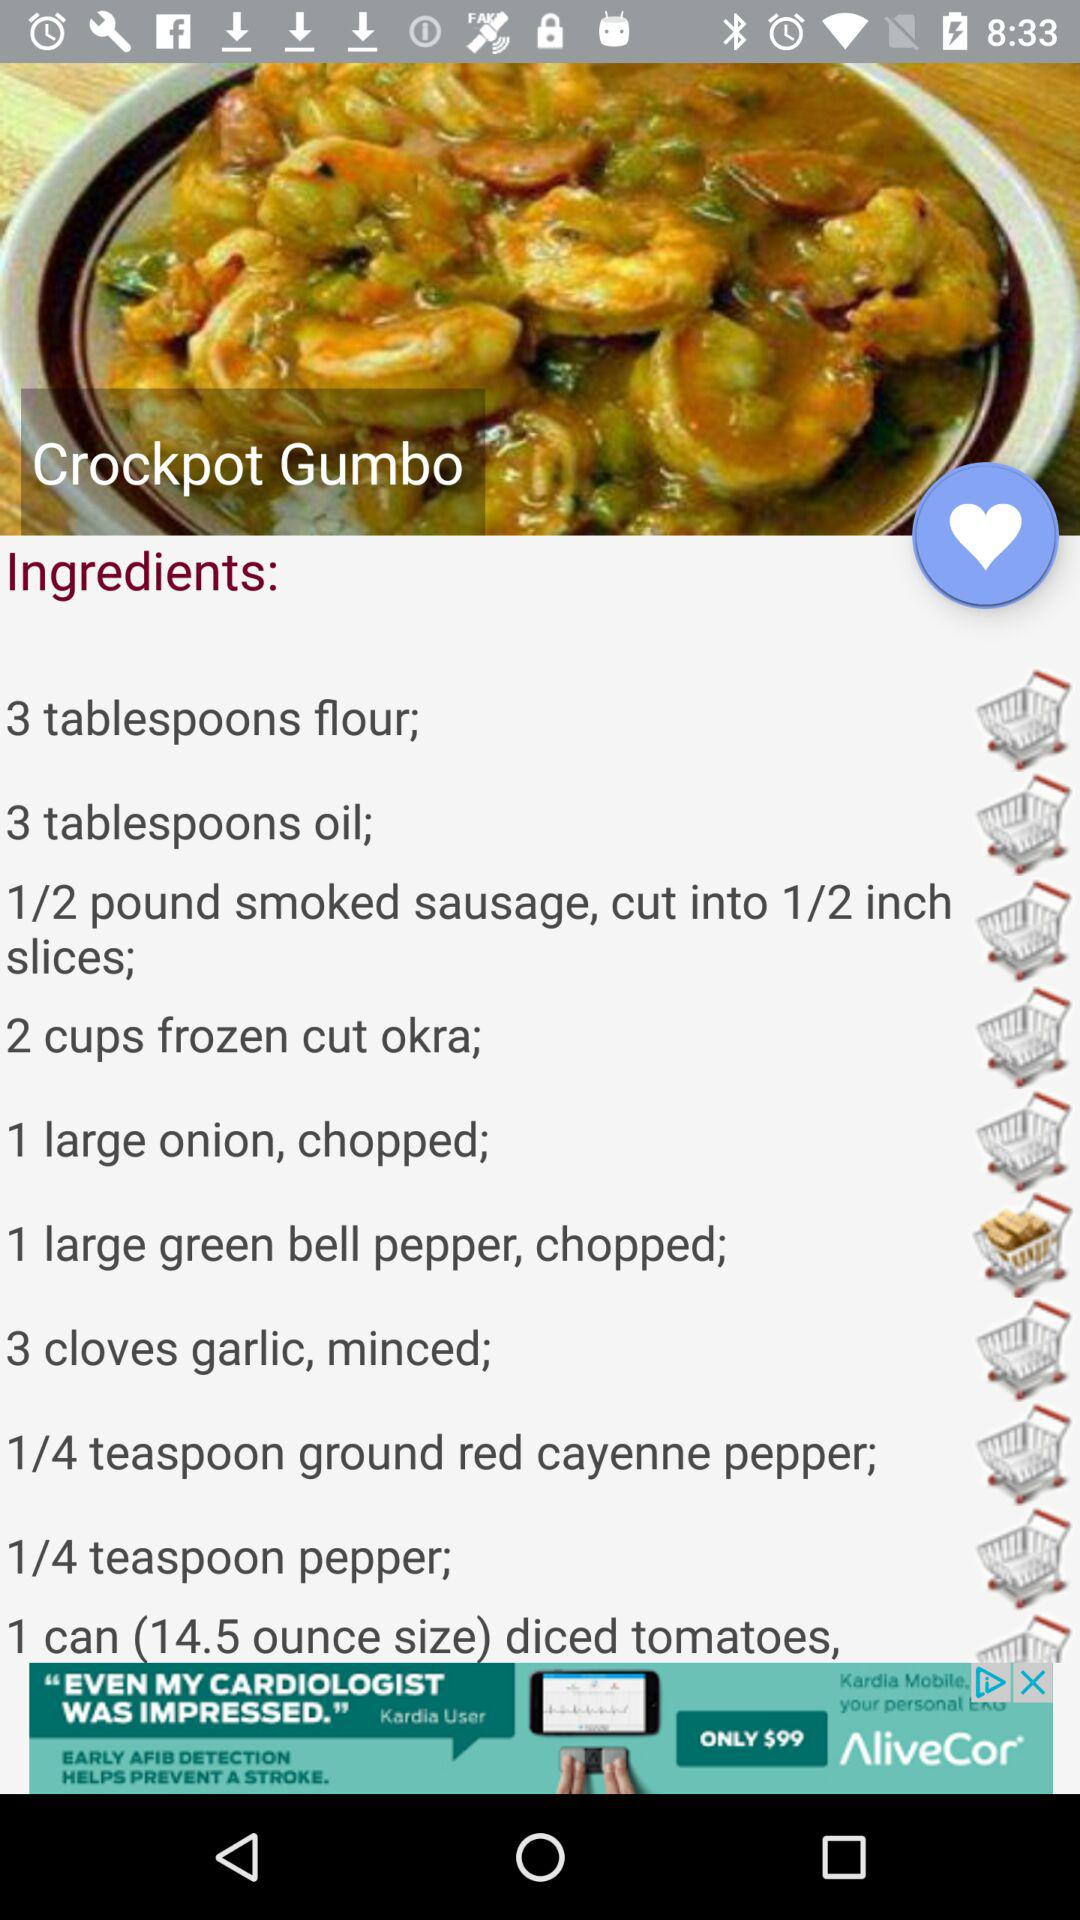How many ingredients are there in this recipe?
Answer the question using a single word or phrase. 10 